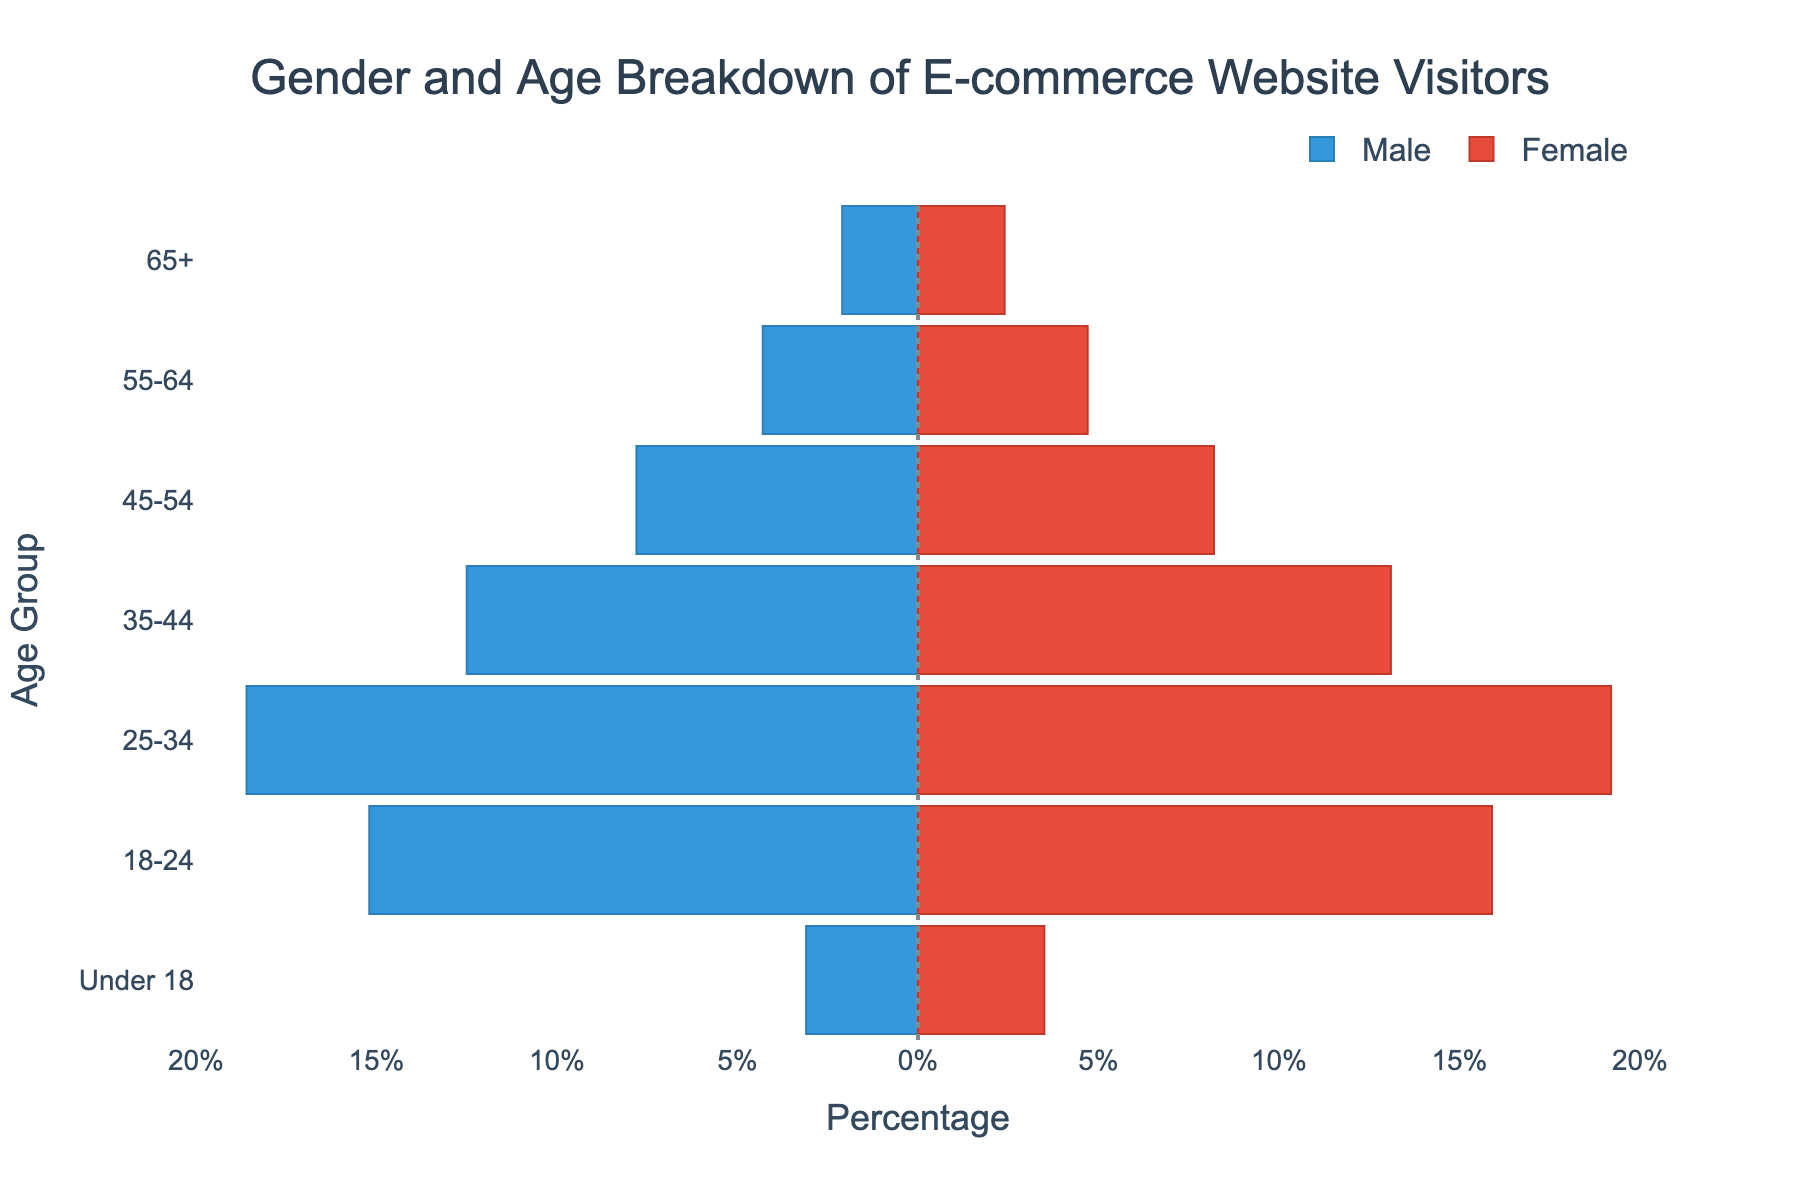What is the title of the figure? The title is located at the top center of the figure in larger, bold text. It reads "Gender and Age Breakdown of E-commerce Website Visitors."
Answer: Gender and Age Breakdown of E-commerce Website Visitors Which age group has the highest percentage of female visitors? To find this, look at the horizontal bar for females (red) in each age group and compare their lengths. The longest red bar is in the "25-34" age group.
Answer: 25-34 What is the total percentage of visitors in the 18-24 age group? Add the percentages of male and female visitors in the 18-24 age group: 15.2% + 15.9% = 31.1%
Answer: 31.1% How does the percentage of male visitors in the 65+ age group compare to female visitors in the same group? Compare the lengths of the bars for males and females in the 65+ age group. The male bar is shorter at 2.1%, and the female bar is slightly longer at 2.4%.
Answer: Female visitors are higher What is the difference in the percentage of visitors between the 35-44 and 45-54 age groups for females? Subtract the percentage of female visitors in the 45-54 age group from those in the 35-44 age group: 13.1% - 8.2% = 4.9%
Answer: 4.9% Which gender has a higher percentage in the 55-64 age group? Compare the lengths of the bars for males and females in the 55-64 age group. The female bar is slightly longer at 4.7%, compared to the male bar at 4.3%.
Answer: Female Are there more male or female visitors under the age of 18? Compare the bars for males and females in the "Under 18" age group. The female bar (3.5%) is longer than the male bar (3.1%).
Answer: Female What age group shows the smallest gender difference in visitation percentages? Look for the age group where the male and female bars are closest in length. The "65+" age group shows the smallest difference between 2.1% for males and 2.4% for females.
Answer: 65+ By how much does the percentage of male visitors in the 25-34 age group exceed that of the 18-24 age group? Subtract the percentage of male visitors in the 18-24 age group from those in the 25-34 age group: 18.6% - 15.2% = 3.4%
Answer: 3.4% Describe the trend of female visitor percentages as age increases from 18-24 to 65+ Female visitation percentages start high in the 18-24 age group, peak in the 25-34 age group, and then generally decline as age increases, falling to the lowest percentage in the 65+ age group.
Answer: Declining trend 